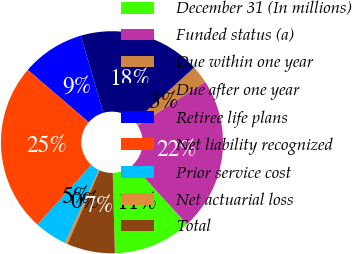Convert chart to OTSL. <chart><loc_0><loc_0><loc_500><loc_500><pie_chart><fcel>December 31 (In millions)<fcel>Funded status (a)<fcel>Due within one year<fcel>Due after one year<fcel>Retiree life plans<fcel>Net liability recognized<fcel>Prior service cost<fcel>Net actuarial loss<fcel>Total<nl><fcel>11.38%<fcel>22.38%<fcel>2.58%<fcel>17.78%<fcel>9.18%<fcel>24.58%<fcel>4.78%<fcel>0.38%<fcel>6.98%<nl></chart> 